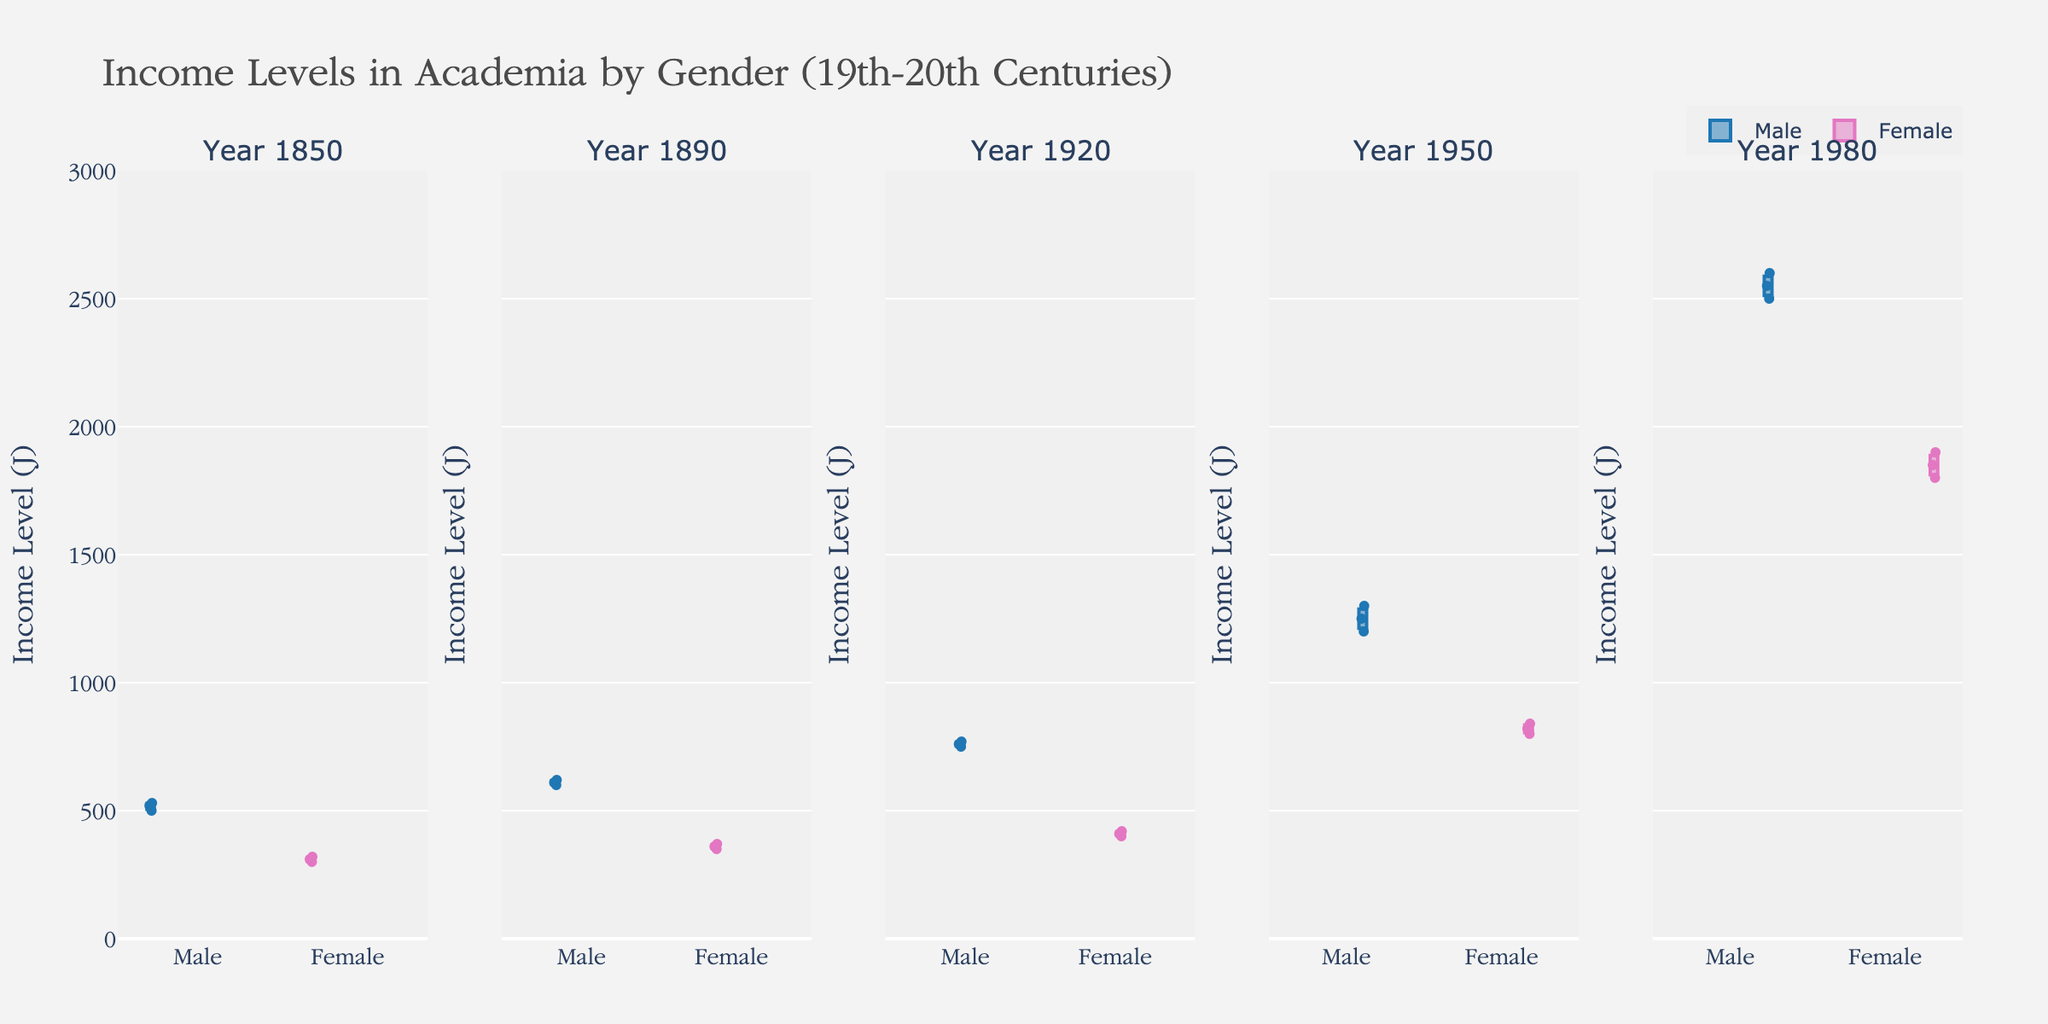What's the title of the figure? The title is located at the top of the plot, which states the subject and time period being studied. Here, the title provides clarity on what the data represents: "Income Levels in Academia by Gender (19th-20th Centuries)"
Answer: Income Levels in Academia by Gender (19th-20th Centuries) What is the highest income level recorded for females in the 20th century? To find the highest female income in the 20th century, look at the box plots for the years 1920, 1950, and 1980. The highest whisker (or data point) among these plots marks the highest value. The female income level in 1980 reaches up to 1900.
Answer: 1900 Which gender had the higher median income level in 1950 and by how much? Observe the median line within each box plot for the year 1950. The male median income line is around 1250, whereas the female median hovers around 820. The difference is calculated as 1250 - 820.
Answer: Male by 430 What is the average income of males in 1850? Identify all male incomes in 1850 from the box plot data points: 500, 520, 530. Calculate the average as (500 + 520 + 530) / 3.
Answer: 516.67 How does the income disparity between males and females change from 1850 to 1980? Look at the difference between male and female median incomes for both years. In 1850, it's about 520 - 310 = 210. In 1980, it's around 2550 - 1850 = 700. The disparity increases from 210 to 700.
Answer: Increases Did the income levels of females show any significant improvement over the observed years? Examine the median income levels for females over the years 1850, 1890, 1920, 1950, and 1980. Each median line shows a progressive increase from approximately 310 in 1850 to 1850 in 1980. This indicates a significant improvement.
Answer: Yes What can be inferred about income equality in academia between genders during the 19th and 20th centuries based on the plot? Compare the median income levels and ranges (boxes and whiskers) of males and females over the years. Initially, the disparity is smaller but grows significantly by 1980, indicating increasing income inequality.
Answer: Increasing inequality 